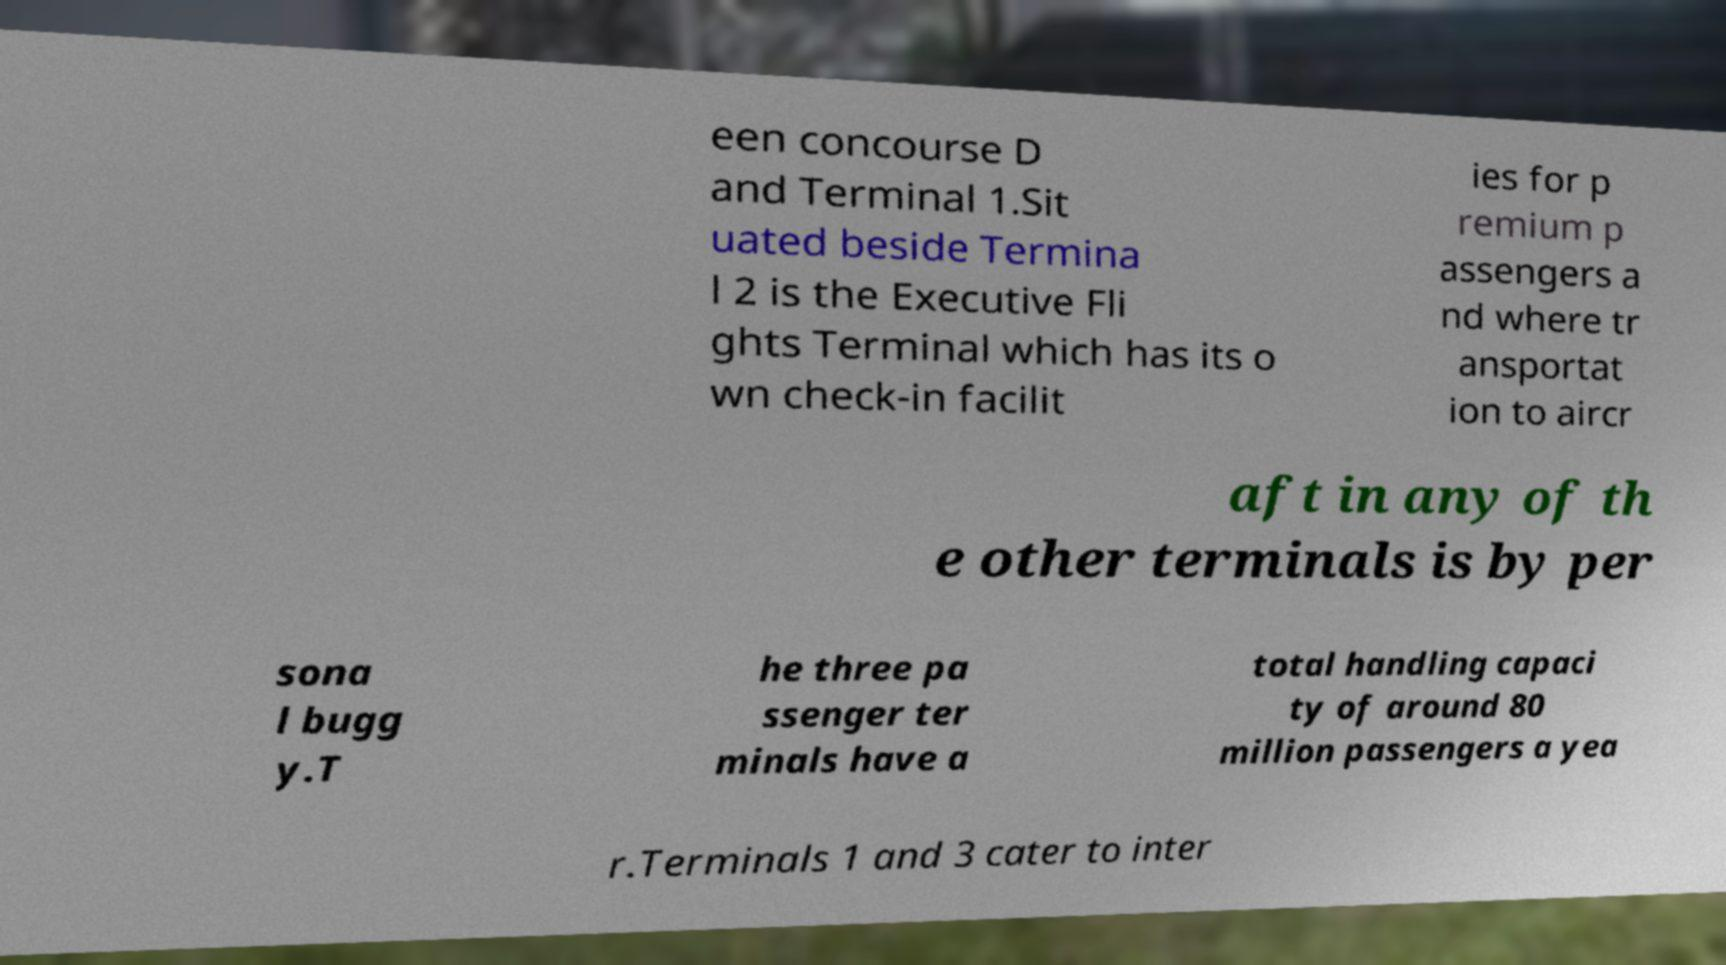Can you accurately transcribe the text from the provided image for me? een concourse D and Terminal 1.Sit uated beside Termina l 2 is the Executive Fli ghts Terminal which has its o wn check-in facilit ies for p remium p assengers a nd where tr ansportat ion to aircr aft in any of th e other terminals is by per sona l bugg y.T he three pa ssenger ter minals have a total handling capaci ty of around 80 million passengers a yea r.Terminals 1 and 3 cater to inter 